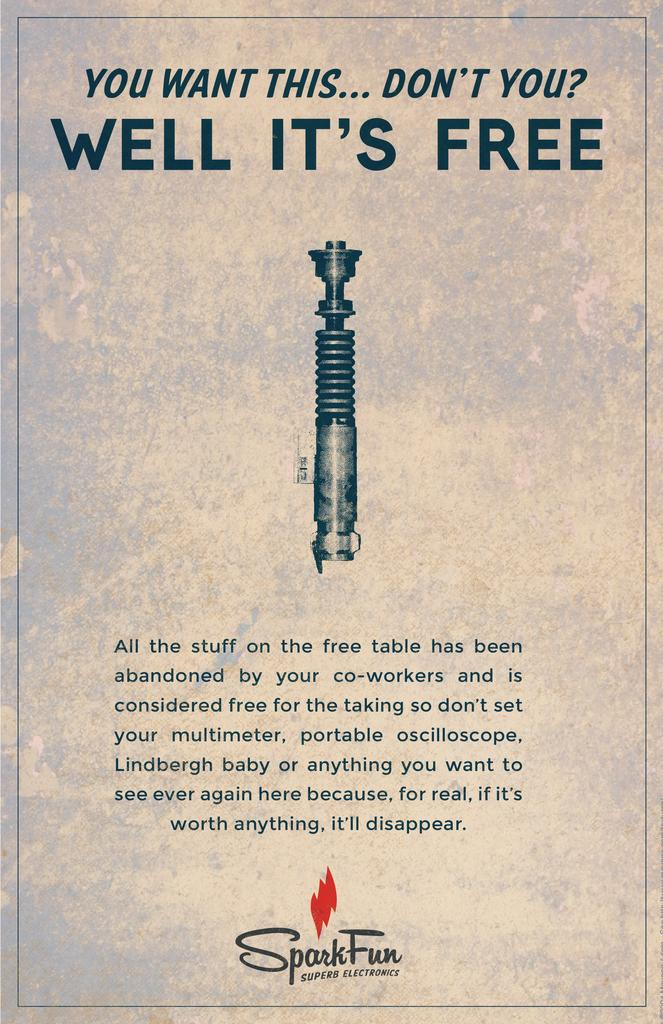<image>
Give a short and clear explanation of the subsequent image. A sign from spark fun about everying on a table being free. 